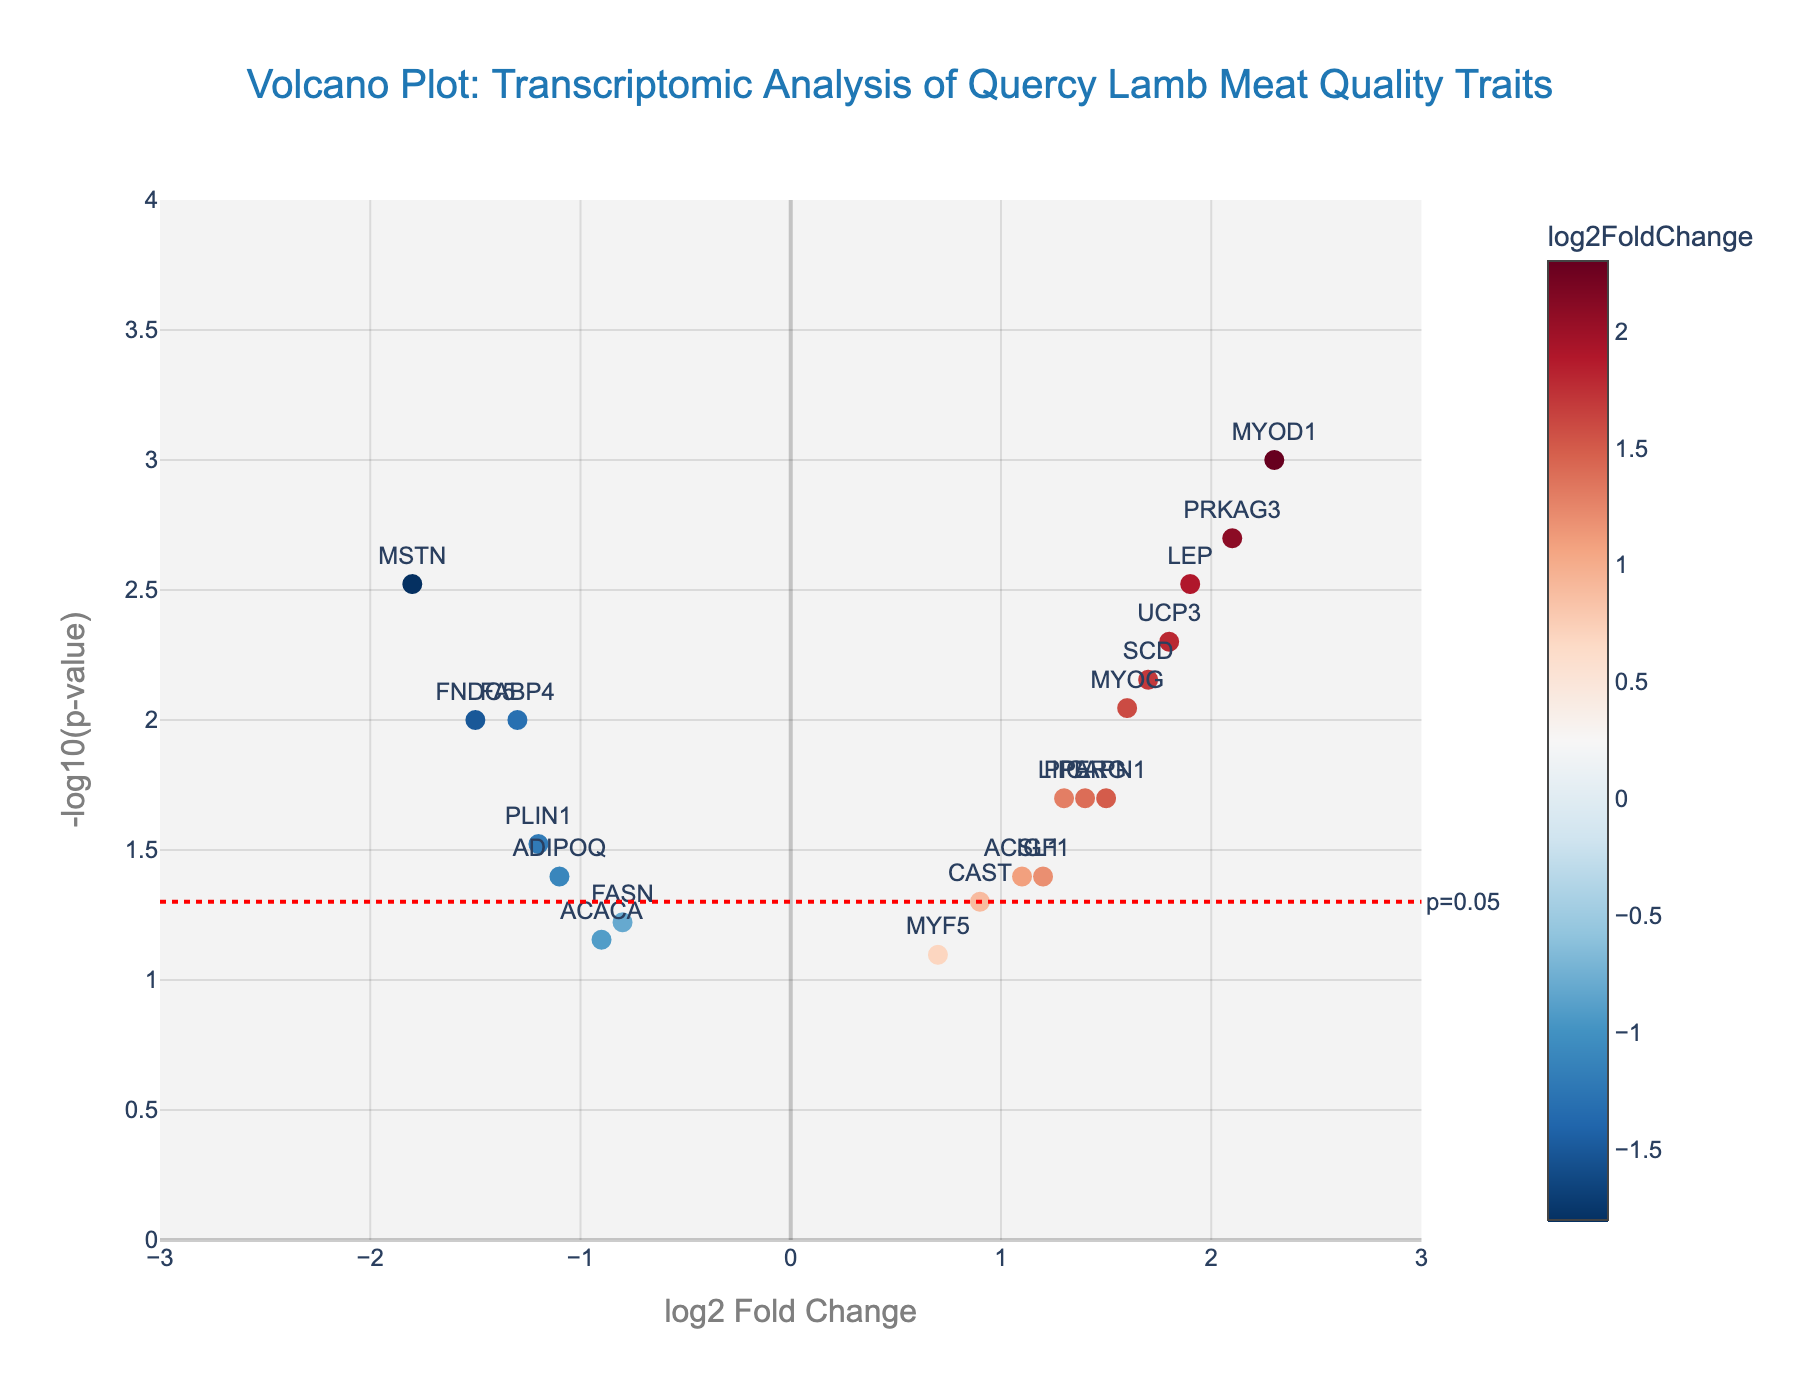What is the main title of the figure? The main title is displayed at the top center of the figure. It reads "Volcano Plot: Transcriptomic Analysis of Quercy Lamb Meat Quality Traits".
Answer: Volcano Plot: Transcriptomic Analysis of Quercy Lamb Meat Quality Traits What is represented on the x-axis and y-axis of the plot? The x-axis represents the "log2 Fold Change" and the y-axis represents the "-log10(p-value)". These labels are displayed next to the respective axes.
Answer: log2 Fold Change, -log10(p-value) How many genes have a p-value less than 0.05? Points with a p-value less than 0.05 will be above the horizontal red dotted line in the plot. Count the number of points above this line.
Answer: 14 Which gene has the highest log2 Fold Change value and what is that value? To find the gene with the highest log2 Fold Change, look for the point farthest to the right on the x-axis. The gene label will be near this point.
Answer: MYOD1, 2.3 Which gene has the lowest log2 Fold Change value and what is that value? To find the gene with the lowest log2 Fold Change, look for the point farthest to the left on the x-axis. The gene label will be near this point.
Answer: MSTN, -1.8 Which gene exhibits the smallest p-value? The smallest p-value corresponds to the highest value on the y-axis. Identify the point that is the highest vertically.
Answer: MYOD1 What is the log2 Fold Change and p-value of the MYOG gene? Locate the MYOG gene label on the plot and note the corresponding x-axis (log2 Fold Change) and y-axis (-log10(p-value)) values. By reversing the transformation for the y-axis value, compute the p-value.
Answer: log2FC: 1.6, p-value: 0.009 How many genes have a negative log2 Fold Change? Points with negative log2 Fold Change values lie to the left of the vertical zero line on the x-axis. Count these points.
Answer: 7 Which genes have a log2 Fold Change greater than 1 and a p-value less than 0.01? Identify points to the right of log2 Fold Change of 1 on the x-axis and above the -log10(0.01) value on the y-axis. Note the gene labels for these points.
Answer: MYOD1, PRKAG3, LEP, SCD, UCP3, MYOG What is the range of the y-axis in this plot? Examine the y-axis limits. The plot's y-axis ranges from 0 to 4 as indicated by the axis labels.
Answer: 0 to 4 